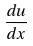<formula> <loc_0><loc_0><loc_500><loc_500>\frac { d u } { d x }</formula> 